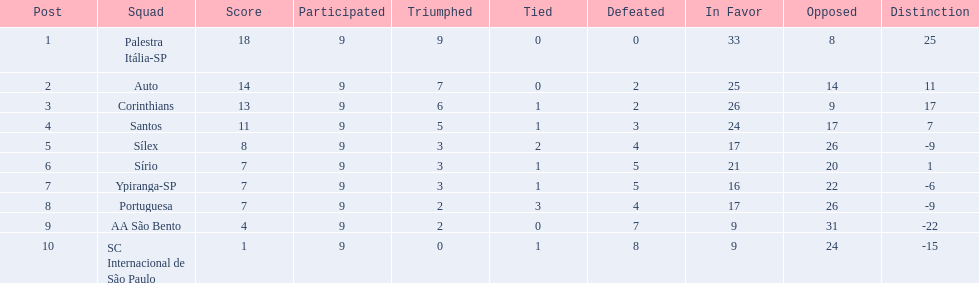What teams played in 1926? Palestra Itália-SP, Auto, Corinthians, Santos, Sílex, Sírio, Ypiranga-SP, Portuguesa, AA São Bento, SC Internacional de São Paulo. Did any team lose zero games? Palestra Itália-SP. 